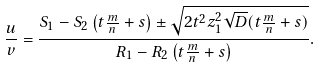<formula> <loc_0><loc_0><loc_500><loc_500>\frac { u } { v } = \frac { S _ { 1 } - S _ { 2 } \left ( t \frac { m } { n } + s \right ) \pm \sqrt { 2 t ^ { 2 } z _ { 1 } ^ { 2 } \sqrt { D } ( t \frac { m } { n } + s ) } } { R _ { 1 } - R _ { 2 } \left ( t \frac { m } { n } + s \right ) } .</formula> 